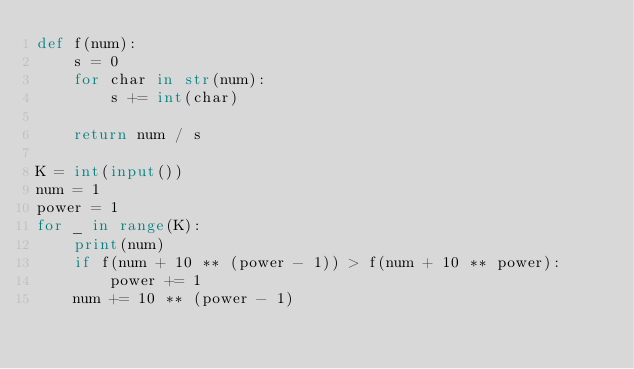Convert code to text. <code><loc_0><loc_0><loc_500><loc_500><_Python_>def f(num):
    s = 0
    for char in str(num):
        s += int(char)

    return num / s

K = int(input())
num = 1
power = 1
for _ in range(K):
    print(num)
    if f(num + 10 ** (power - 1)) > f(num + 10 ** power):
        power += 1
    num += 10 ** (power - 1)</code> 